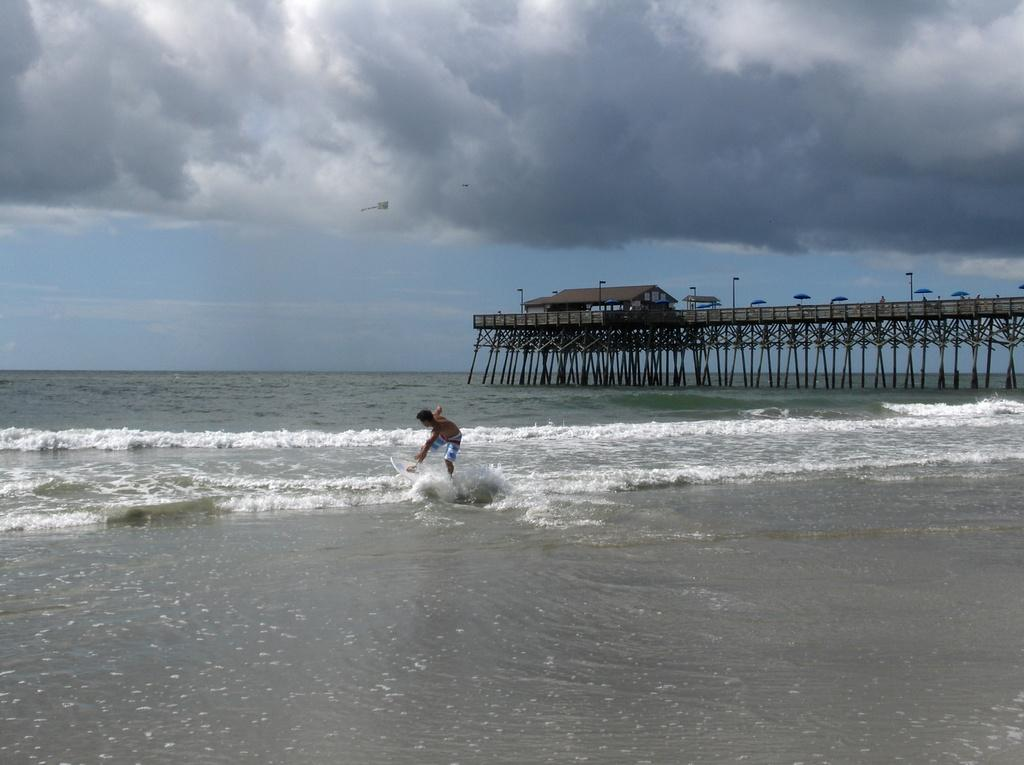Who is present in the image? There is a man in the image. What is visible in the image besides the man? Water, a bridge, umbrellas, a house, light poles, and the sky are visible in the image. What type of structure can be seen in the image? There is a bridge in the image. What might be used for protection from the rain in the image? Umbrellas are present in the image for protection from the rain. What is visible in the background of the image? The sky is visible in the background of the image, with clouds present. What type of animal can be seen resting on the bridge in the image? There is no animal resting on the bridge in the image. 